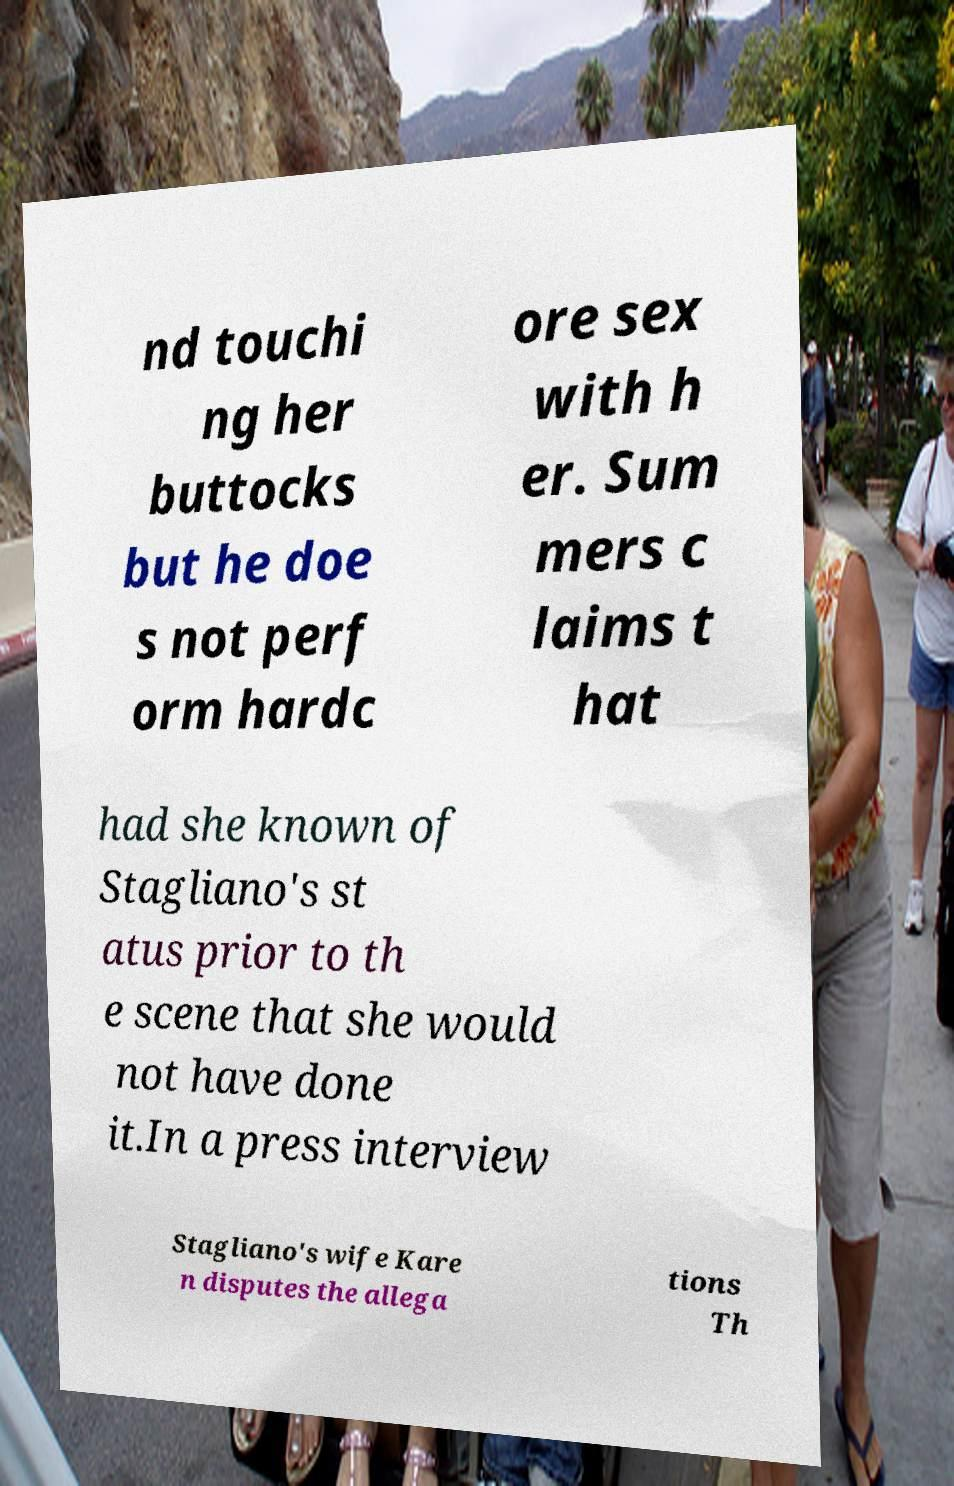Can you read and provide the text displayed in the image?This photo seems to have some interesting text. Can you extract and type it out for me? nd touchi ng her buttocks but he doe s not perf orm hardc ore sex with h er. Sum mers c laims t hat had she known of Stagliano's st atus prior to th e scene that she would not have done it.In a press interview Stagliano's wife Kare n disputes the allega tions Th 